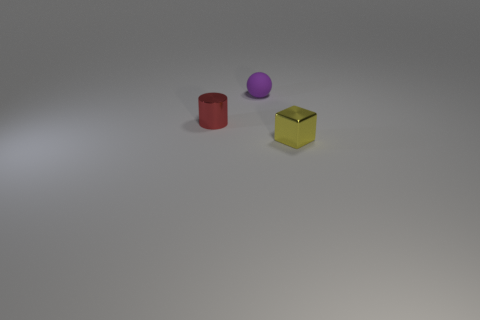How many objects are yellow metallic blocks or small red metal cylinders?
Provide a short and direct response. 2. The ball that is the same size as the yellow shiny cube is what color?
Ensure brevity in your answer.  Purple. How many metal things are behind the thing behind the small red metal cylinder?
Provide a short and direct response. 0. What number of tiny objects are on the right side of the tiny red metal cylinder and in front of the matte object?
Your response must be concise. 1. What number of things are things that are behind the small red object or tiny objects behind the red cylinder?
Make the answer very short. 1. How many other objects are the same size as the red thing?
Ensure brevity in your answer.  2. What is the shape of the object behind the tiny shiny object that is to the left of the yellow metal block?
Give a very brief answer. Sphere. There is a tiny metallic object on the right side of the red cylinder; is it the same color as the object that is left of the purple matte ball?
Offer a terse response. No. Is there any other thing of the same color as the tiny metallic cube?
Keep it short and to the point. No. The matte ball is what color?
Offer a very short reply. Purple. 